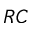<formula> <loc_0><loc_0><loc_500><loc_500>R C</formula> 